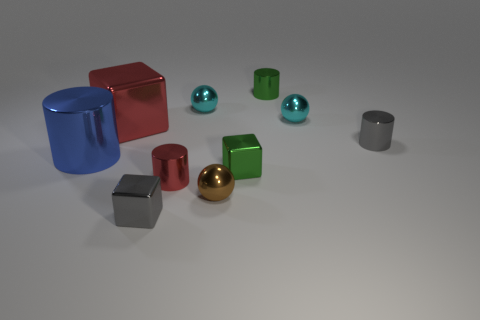Subtract all cubes. How many objects are left? 7 Add 8 blue shiny objects. How many blue shiny objects exist? 9 Subtract 0 red spheres. How many objects are left? 10 Subtract all metallic objects. Subtract all purple cubes. How many objects are left? 0 Add 1 cyan metal things. How many cyan metal things are left? 3 